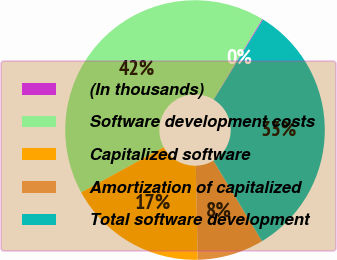Convert chart to OTSL. <chart><loc_0><loc_0><loc_500><loc_500><pie_chart><fcel>(In thousands)<fcel>Software development costs<fcel>Capitalized software<fcel>Amortization of capitalized<fcel>Total software development<nl><fcel>0.12%<fcel>41.65%<fcel>17.36%<fcel>8.29%<fcel>32.59%<nl></chart> 